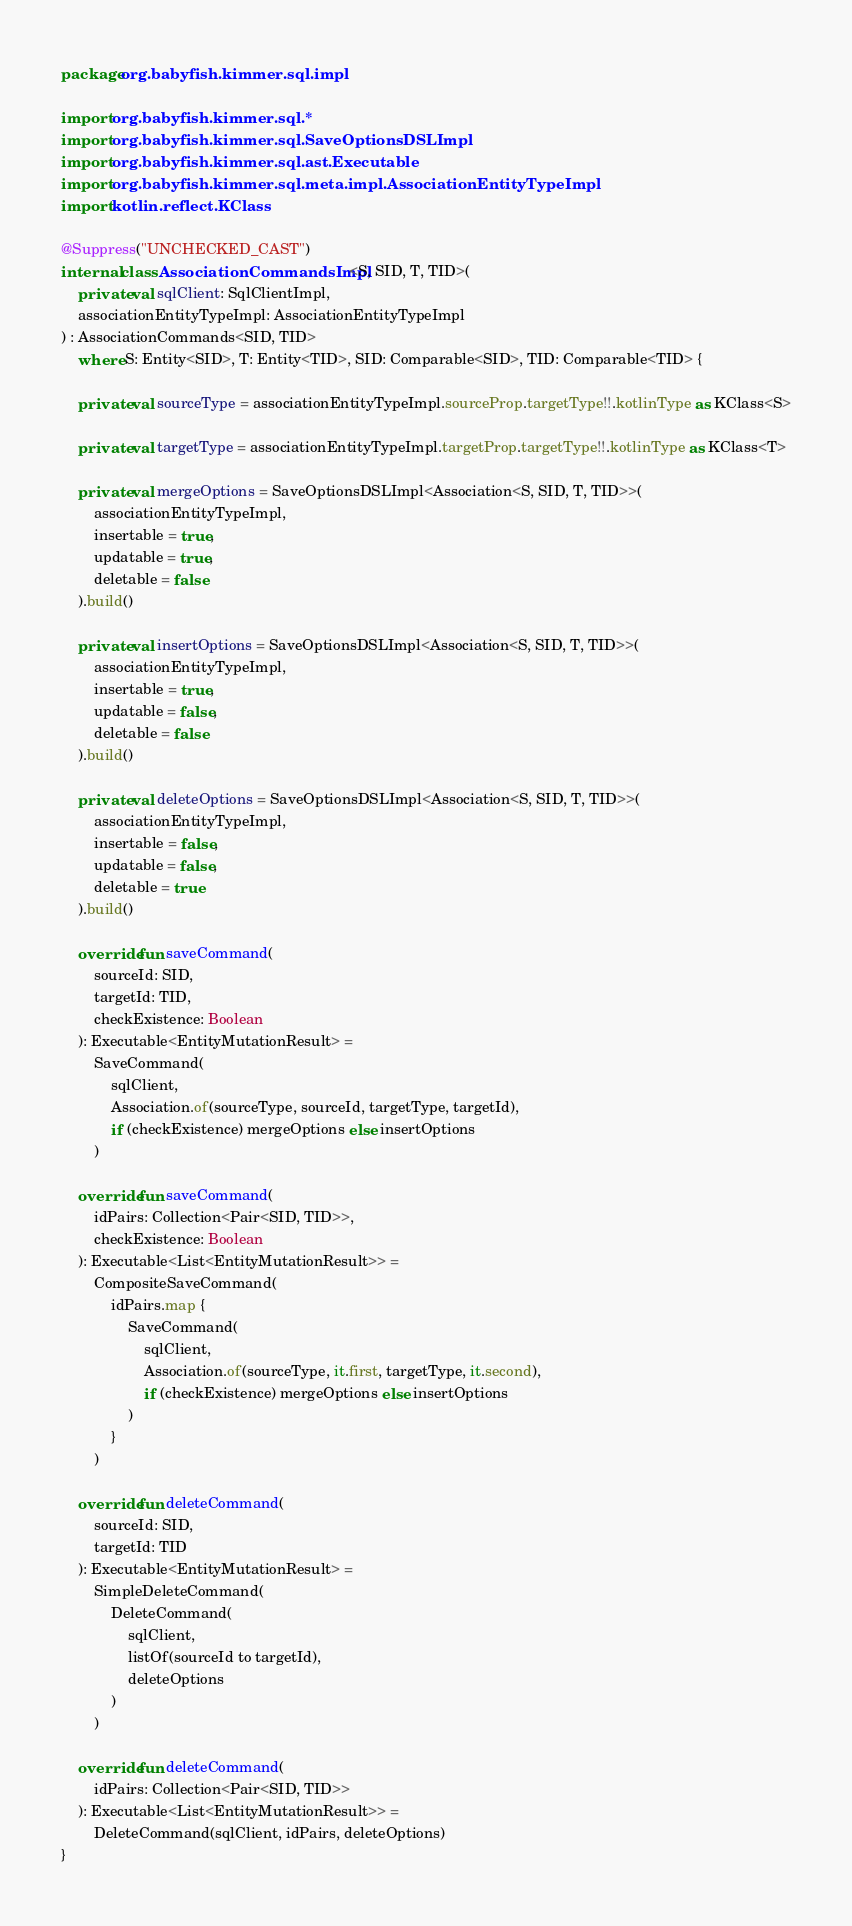Convert code to text. <code><loc_0><loc_0><loc_500><loc_500><_Kotlin_>package org.babyfish.kimmer.sql.impl

import org.babyfish.kimmer.sql.*
import org.babyfish.kimmer.sql.SaveOptionsDSLImpl
import org.babyfish.kimmer.sql.ast.Executable
import org.babyfish.kimmer.sql.meta.impl.AssociationEntityTypeImpl
import kotlin.reflect.KClass

@Suppress("UNCHECKED_CAST")
internal class AssociationCommandsImpl<S, SID, T, TID>(
    private val sqlClient: SqlClientImpl,
    associationEntityTypeImpl: AssociationEntityTypeImpl
) : AssociationCommands<SID, TID>
    where S: Entity<SID>, T: Entity<TID>, SID: Comparable<SID>, TID: Comparable<TID> {

    private val sourceType = associationEntityTypeImpl.sourceProp.targetType!!.kotlinType as KClass<S>

    private val targetType = associationEntityTypeImpl.targetProp.targetType!!.kotlinType as KClass<T>

    private val mergeOptions = SaveOptionsDSLImpl<Association<S, SID, T, TID>>(
        associationEntityTypeImpl,
        insertable = true,
        updatable = true,
        deletable = false
    ).build()

    private val insertOptions = SaveOptionsDSLImpl<Association<S, SID, T, TID>>(
        associationEntityTypeImpl,
        insertable = true,
        updatable = false,
        deletable = false
    ).build()

    private val deleteOptions = SaveOptionsDSLImpl<Association<S, SID, T, TID>>(
        associationEntityTypeImpl,
        insertable = false,
        updatable = false,
        deletable = true
    ).build()

    override fun saveCommand(
        sourceId: SID,
        targetId: TID,
        checkExistence: Boolean
    ): Executable<EntityMutationResult> =
        SaveCommand(
            sqlClient,
            Association.of(sourceType, sourceId, targetType, targetId),
            if (checkExistence) mergeOptions else insertOptions
        )

    override fun saveCommand(
        idPairs: Collection<Pair<SID, TID>>,
        checkExistence: Boolean
    ): Executable<List<EntityMutationResult>> =
        CompositeSaveCommand(
            idPairs.map {
                SaveCommand(
                    sqlClient,
                    Association.of(sourceType, it.first, targetType, it.second),
                    if (checkExistence) mergeOptions else insertOptions
                )
            }
        )

    override fun deleteCommand(
        sourceId: SID,
        targetId: TID
    ): Executable<EntityMutationResult> =
        SimpleDeleteCommand(
            DeleteCommand(
                sqlClient,
                listOf(sourceId to targetId),
                deleteOptions
            )
        )

    override fun deleteCommand(
        idPairs: Collection<Pair<SID, TID>>
    ): Executable<List<EntityMutationResult>> =
        DeleteCommand(sqlClient, idPairs, deleteOptions)
}</code> 